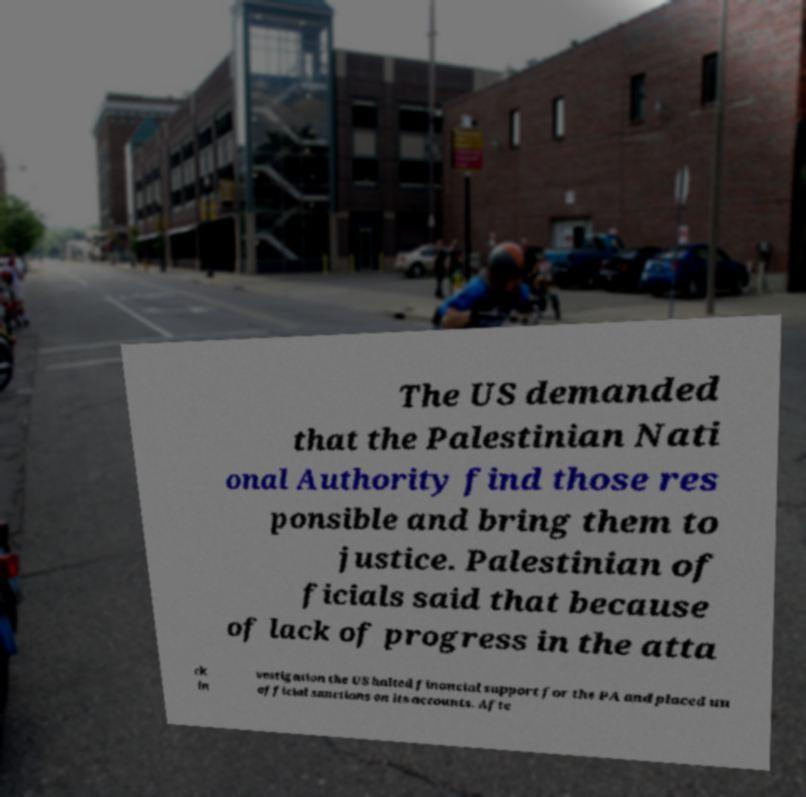There's text embedded in this image that I need extracted. Can you transcribe it verbatim? The US demanded that the Palestinian Nati onal Authority find those res ponsible and bring them to justice. Palestinian of ficials said that because of lack of progress in the atta ck in vestigation the US halted financial support for the PA and placed un official sanctions on its accounts. Afte 